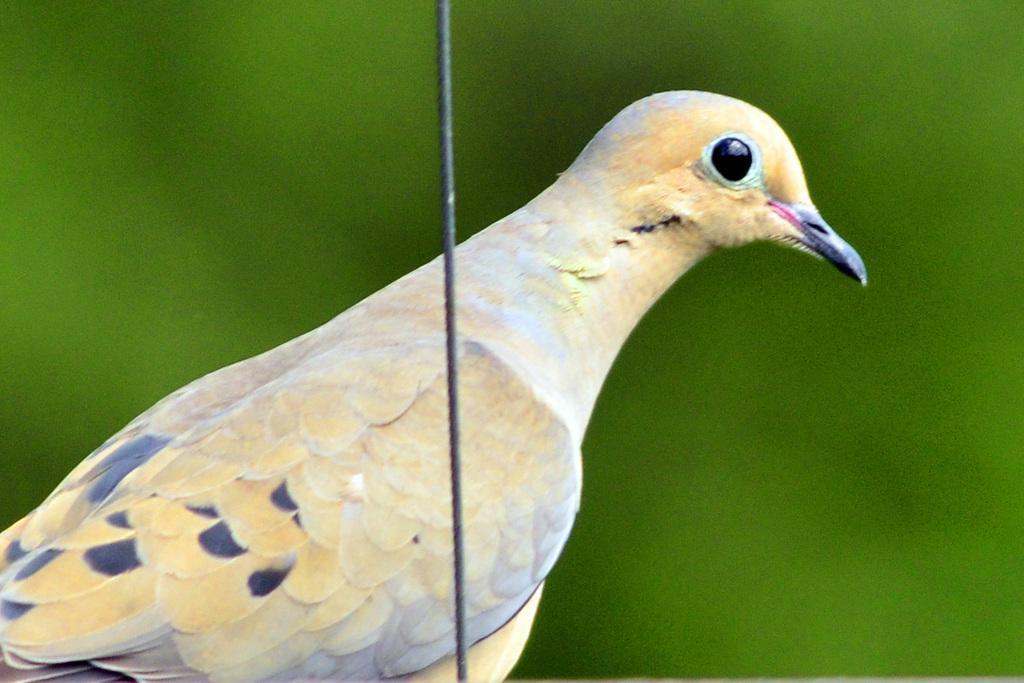Please provide a concise description of this image. In this image I see a bird over here which is of cream, white and black in color and I see the black color wire over here and I see that it is totally green in the background. 